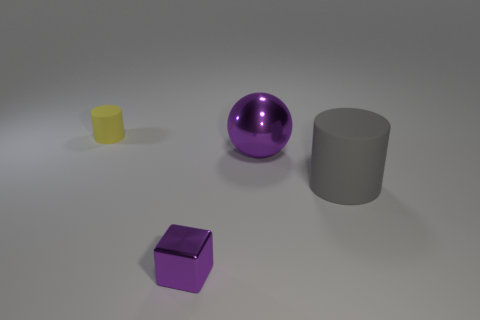There is a thing that is the same material as the large sphere; what color is it?
Make the answer very short. Purple. Are there fewer blue shiny objects than big gray objects?
Your answer should be compact. Yes. What is the thing that is to the right of the tiny matte object and behind the large rubber thing made of?
Provide a short and direct response. Metal. Is there a gray cylinder that is right of the rubber object that is in front of the tiny cylinder?
Provide a short and direct response. No. What number of tiny metallic objects are the same color as the metallic sphere?
Your answer should be very brief. 1. What is the material of the sphere that is the same color as the tiny block?
Offer a very short reply. Metal. Is the material of the yellow thing the same as the purple block?
Provide a short and direct response. No. There is a big purple metal object; are there any purple metallic objects in front of it?
Offer a very short reply. Yes. The cylinder that is to the left of the small thing that is in front of the gray thing is made of what material?
Ensure brevity in your answer.  Rubber. What size is the gray matte object that is the same shape as the yellow object?
Provide a succinct answer. Large. 